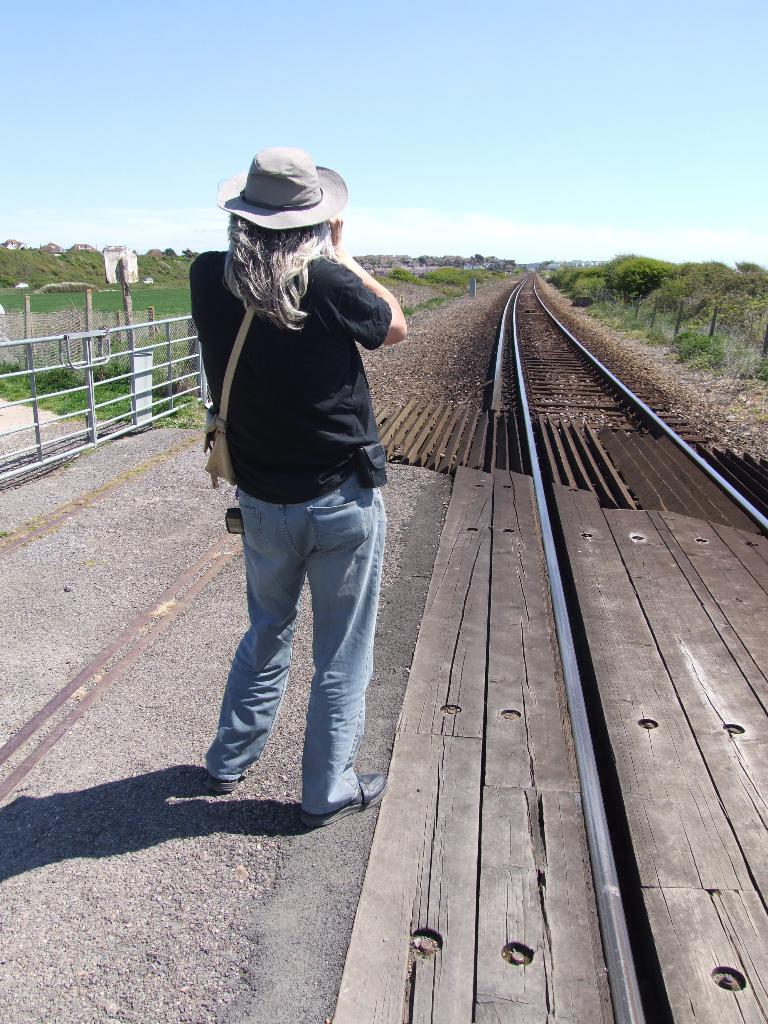Who or what is present in the image? There is a person in the image. What is the person doing or where are they located? The person is beside a track. What can be seen on the left side of the image? There is a gate on the left side of the image. What is visible at the top of the image? The sky is visible at the top of the image. Can you see a snake slithering near the person in the image? No, there is no snake present in the image. What type of education is the person receiving in the image? There is no indication of education in the image; it simply shows a person beside a track. 